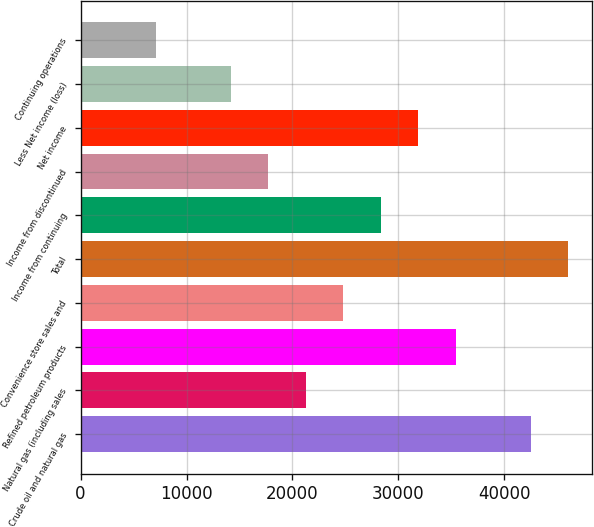<chart> <loc_0><loc_0><loc_500><loc_500><bar_chart><fcel>Crude oil and natural gas<fcel>Natural gas (including sales<fcel>Refined petroleum products<fcel>Convenience store sales and<fcel>Total<fcel>Income from continuing<fcel>Income from discontinued<fcel>Net income<fcel>Less Net income (loss)<fcel>Continuing operations<nl><fcel>42475.1<fcel>21237.8<fcel>35396<fcel>24777.3<fcel>46014.7<fcel>28316.9<fcel>17698.2<fcel>31856.4<fcel>14158.6<fcel>7079.52<nl></chart> 